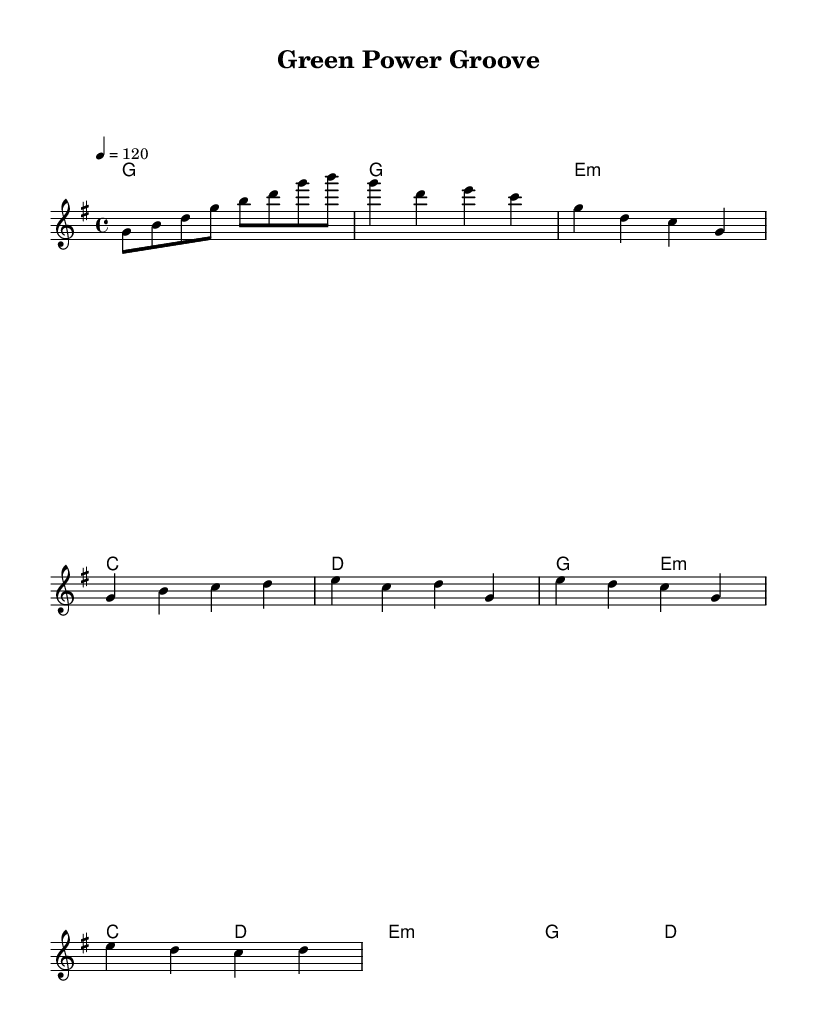What is the key signature of this music? The key signature is G major, which contains one sharp. This is indicated at the beginning of the staff with an F sharp symbol.
Answer: G major What is the time signature of this piece? The time signature is 4/4, as shown at the beginning of the score. This means there are four beats in each measure.
Answer: 4/4 What is the tempo marking for this piece? The tempo marking indicates 120 beats per minute, which is specified in the tempo indication at the start of the sheet music.
Answer: 120 How many measures are in the verse? The verse consists of 4 measures, represented by the four groups of notes under the 'Verse' section.
Answer: 4 What is the first chord of the chorus? The first chord of the chorus is G major, as indicated by the chord name above the notes in the chorus section.
Answer: G What environmental themes are expressed in the lyrics? The lyrics celebrate solar panels and wind turbines, referring to renewable energy practices. The lyrics are closely related to sustainable energy innovations.
Answer: Renewable energy Which section of the music contains a bridge? The bridge is indicated in the sheet music and follows the structure of the song, appearing distinctly after the chorus, labeled as "Bridge."
Answer: Bridge 